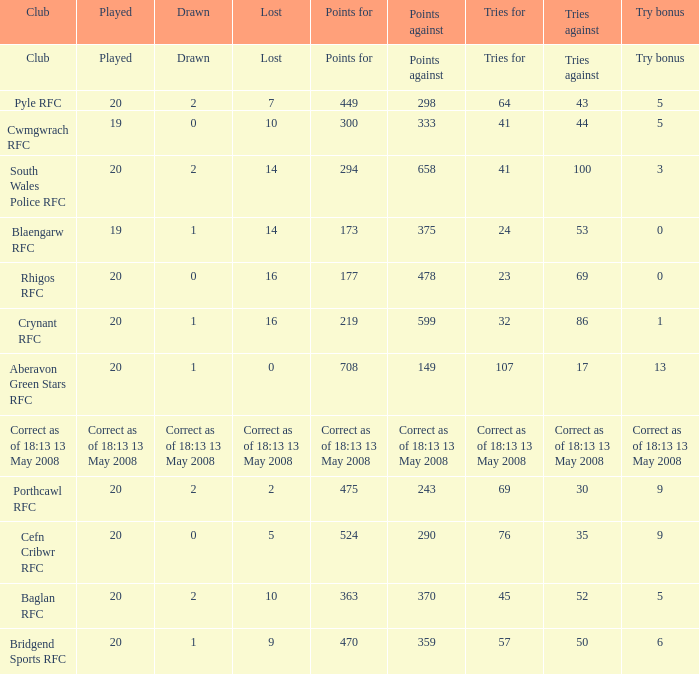What is the tries against when the points are 475? 30.0. 